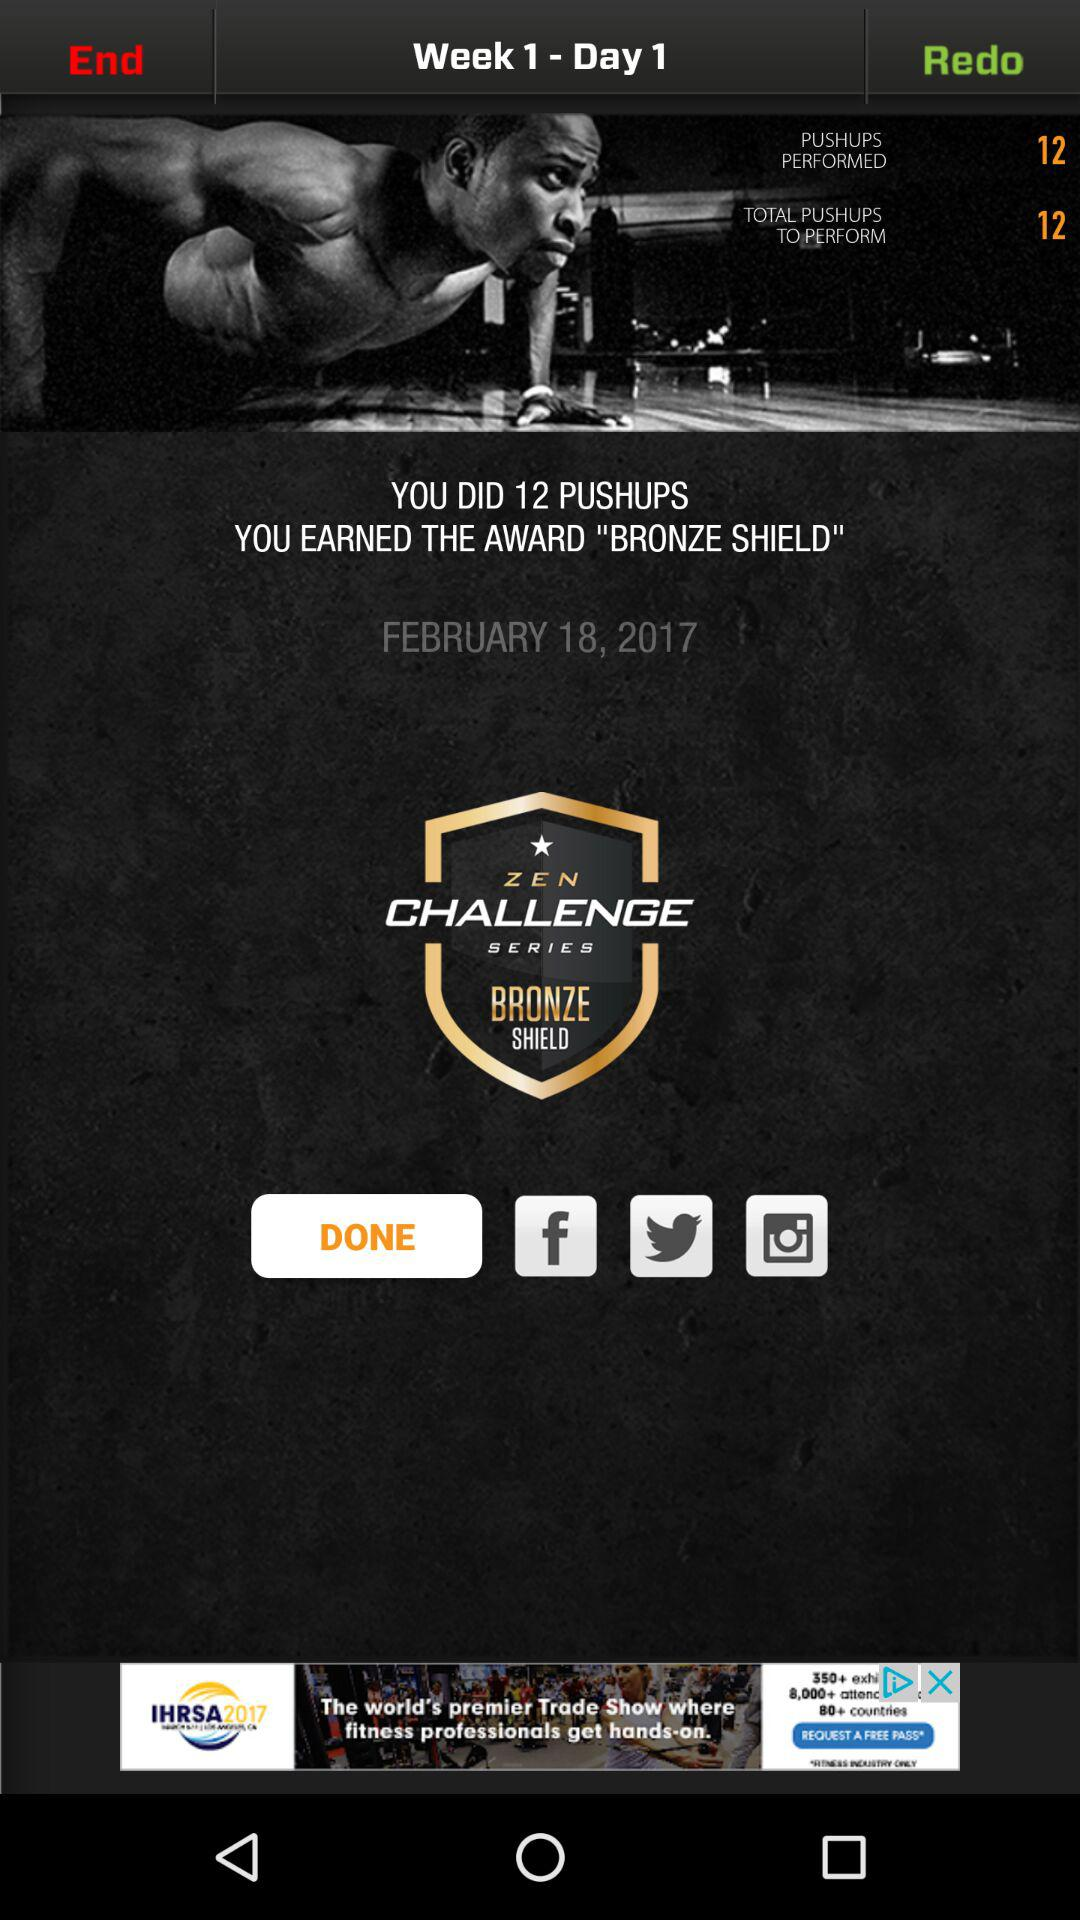How many more pushups do I need to do?
Answer the question using a single word or phrase. 0 